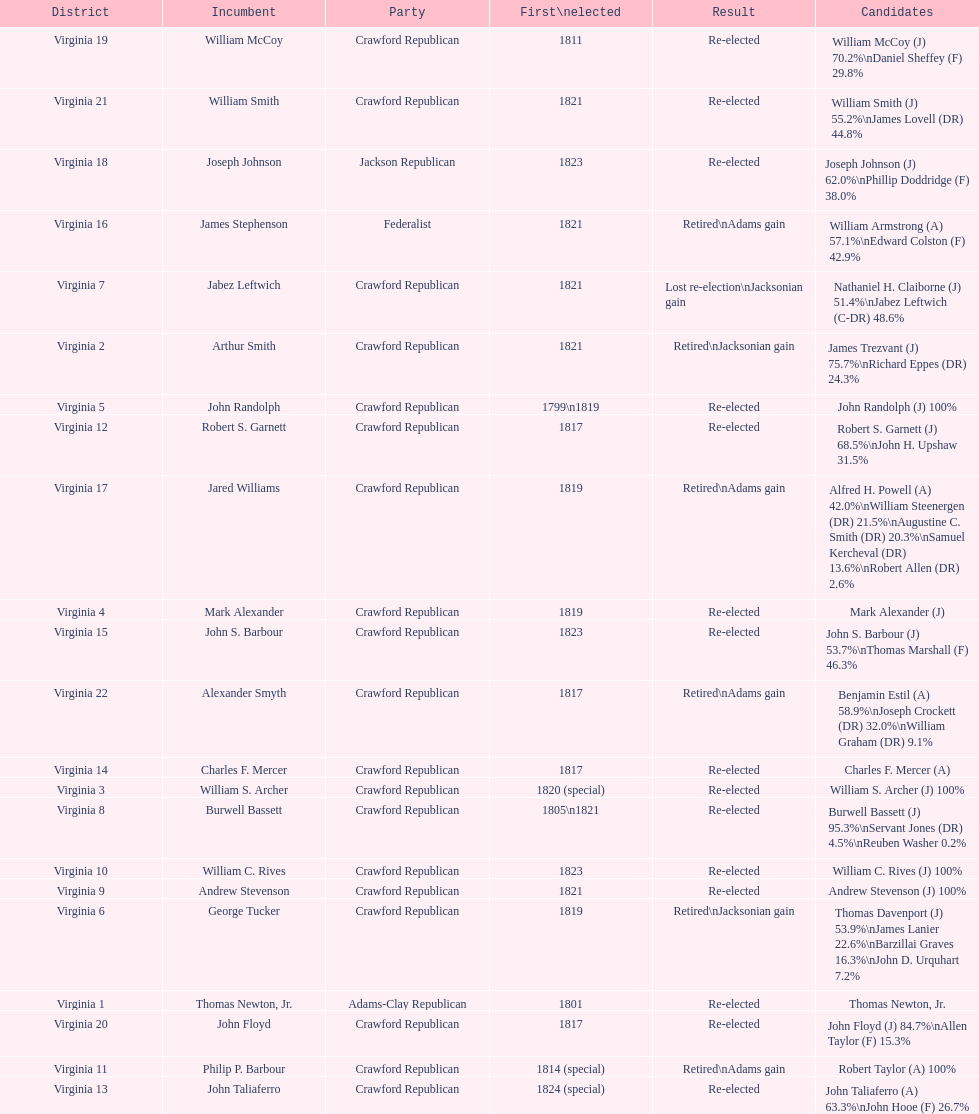In how many cases did incumbents either retire or lose their re-election bid? 7. 